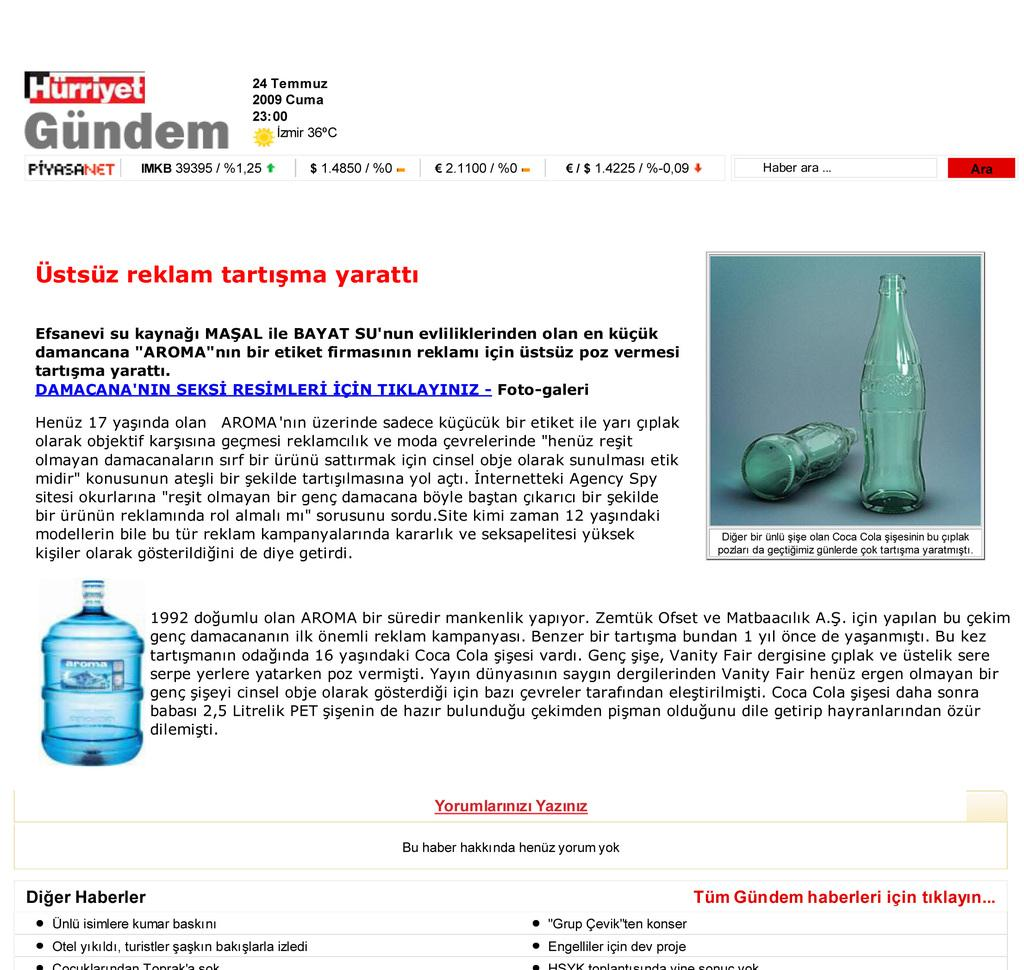<image>
Relay a brief, clear account of the picture shown. a page that is titled 'hurriyet gundem' at the top 